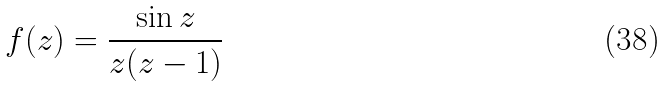Convert formula to latex. <formula><loc_0><loc_0><loc_500><loc_500>f ( z ) = { \frac { \sin z } { z ( z - 1 ) } }</formula> 